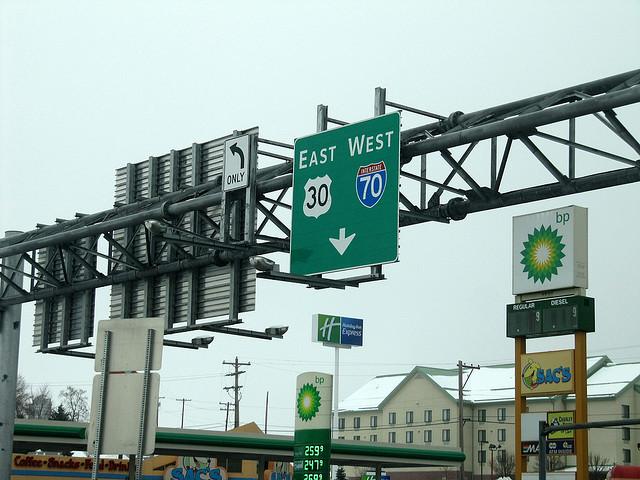How many highway signs are on the pole?
Answer briefly. 3. What directions are given on the road sign towards top of foot?
Write a very short answer. East west. What is the name of the gas station?
Short answer required. Bp. Which direction does one go for Wasatch National Forest?
Give a very brief answer. East. What hotel/motel sign can be seen in the background?
Keep it brief. Holiday inn express. What does the yellow sign say?
Concise answer only. Sac's. 